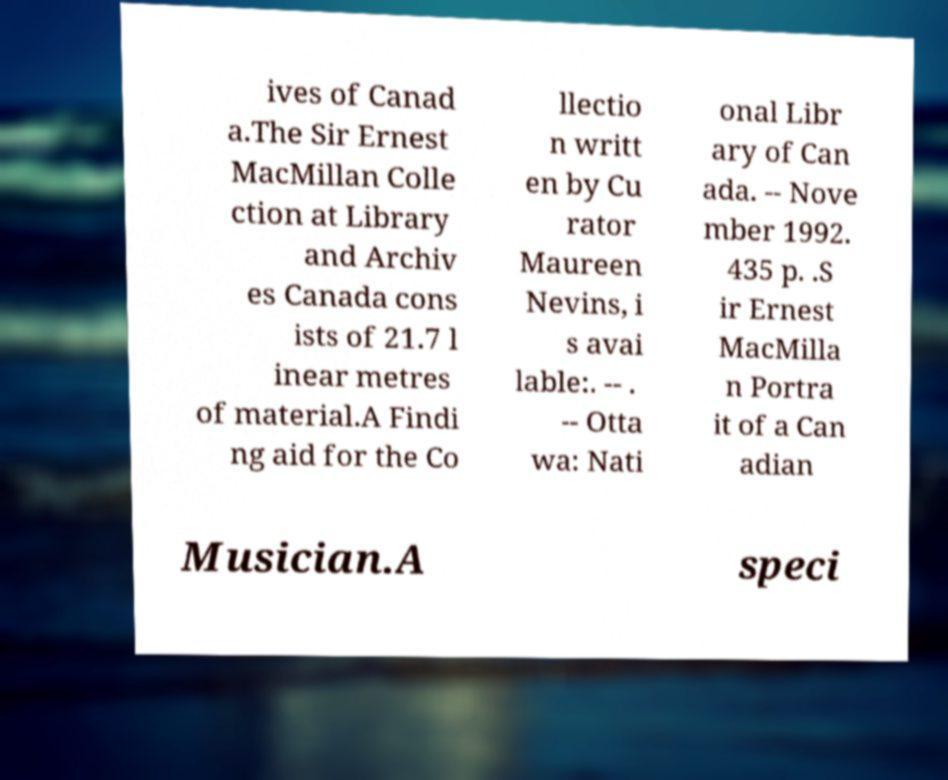I need the written content from this picture converted into text. Can you do that? ives of Canad a.The Sir Ernest MacMillan Colle ction at Library and Archiv es Canada cons ists of 21.7 l inear metres of material.A Findi ng aid for the Co llectio n writt en by Cu rator Maureen Nevins, i s avai lable:. -- . -- Otta wa: Nati onal Libr ary of Can ada. -- Nove mber 1992. 435 p. .S ir Ernest MacMilla n Portra it of a Can adian Musician.A speci 